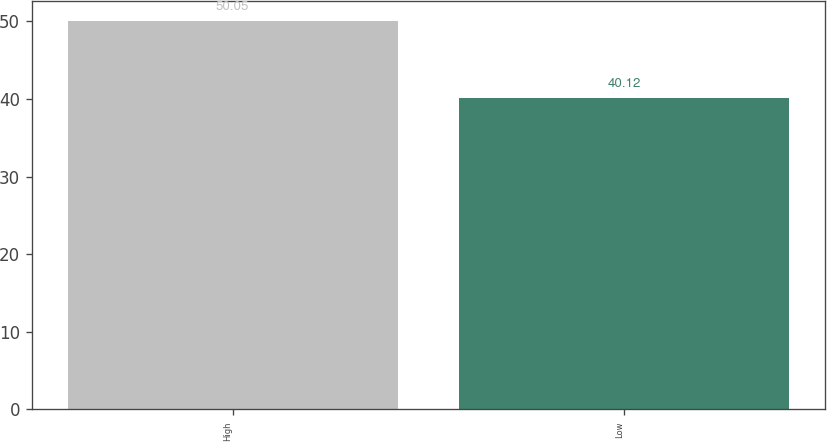<chart> <loc_0><loc_0><loc_500><loc_500><bar_chart><fcel>High<fcel>Low<nl><fcel>50.05<fcel>40.12<nl></chart> 